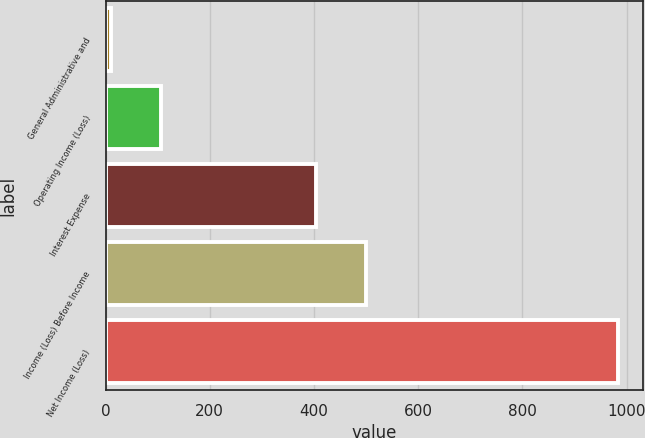Convert chart to OTSL. <chart><loc_0><loc_0><loc_500><loc_500><bar_chart><fcel>General Administrative and<fcel>Operating Income (Loss)<fcel>Interest Expense<fcel>Income (Loss) Before Income<fcel>Net Income (Loss)<nl><fcel>10<fcel>107.3<fcel>403<fcel>500.3<fcel>983<nl></chart> 